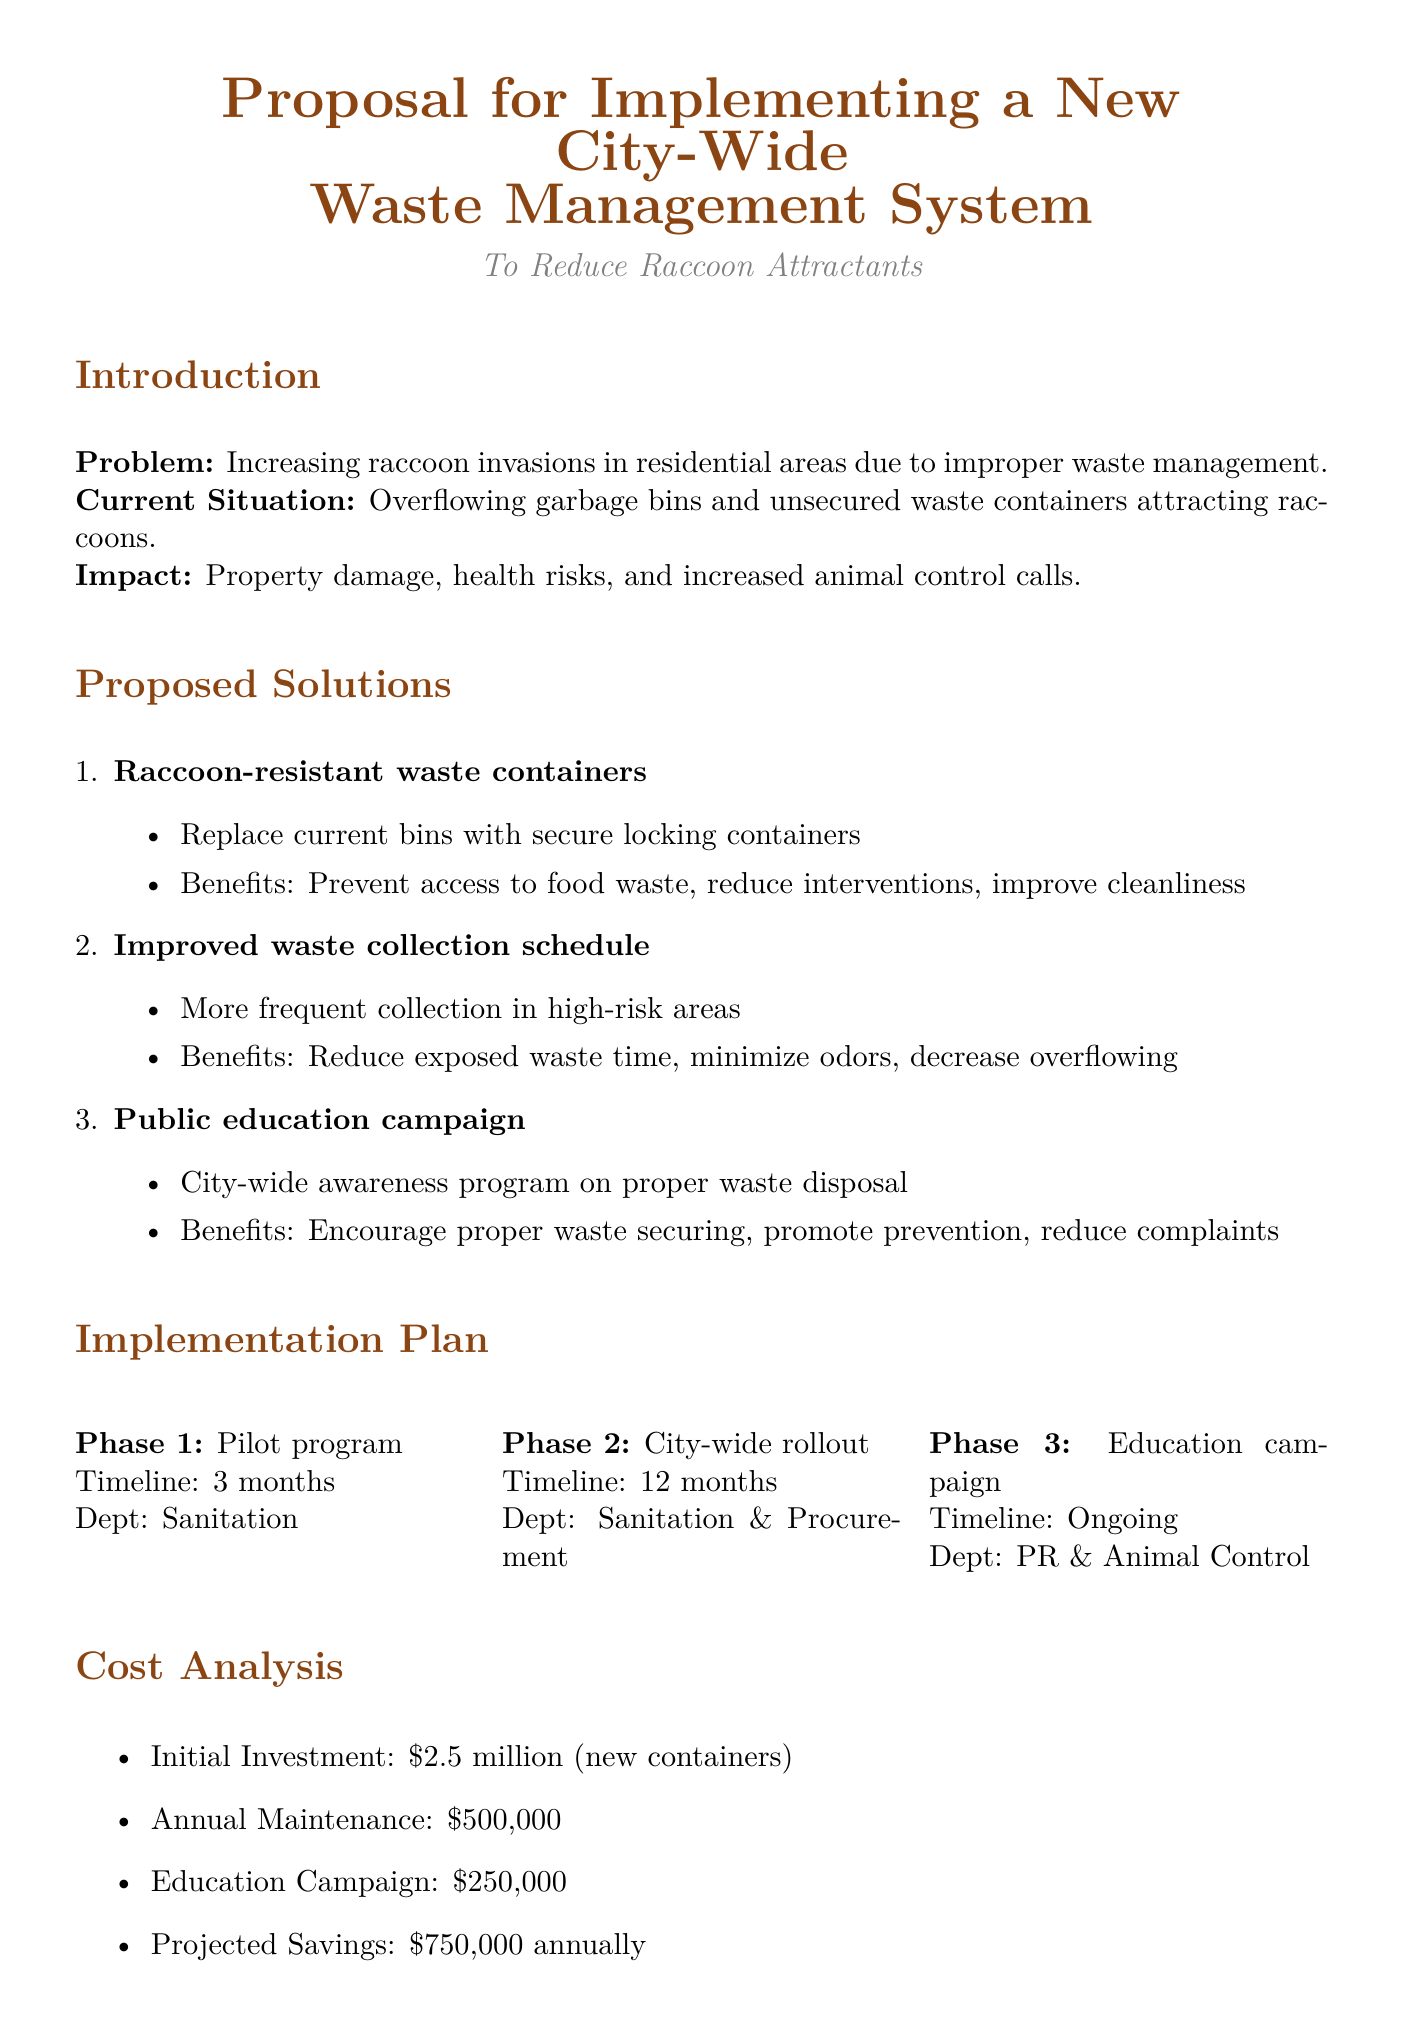What is the main problem addressed in the memo? The memo addresses the increasing raccoon invasions in residential areas due to improper waste management.
Answer: Increasing raccoon invasions What is the proposed initial investment for new waste containers? The proposed initial investment for new waste containers is explicitly stated in the cost analysis section of the document.
Answer: $2.5 million In how many months is the pilot program expected to run? The timeline for the pilot program is mentioned in the implementation plan section.
Answer: 3 months What is one benefit of raccoon-resistant waste containers? The benefits of raccoon-resistant waste containers are outlined in the proposed solutions, detailing why they are effective.
Answer: Prevent raccoons from accessing food waste Who is responsible for the public education campaign? The responsible department for the public education campaign is noted in the implementation plan.
Answer: Public Relations and Animal Control What is the expected reduction in raccoon-related incidents within the first year? The expected outcomes include specific projections regarding raccoon-related incidents, highlighting the effectiveness of the proposed plan.
Answer: 50% reduction What is the annual maintenance cost for container repairs and replacements? The annual maintenance cost is clearly stated in the cost analysis section of the document.
Answer: $500,000 What is the role of local wildlife rehabilitation centers in this proposal? The collaboration opportunities section outlines the specific roles for each partner in the initiative.
Answer: Provide expertise on raccoon behavior and humane deterrence methods What is the call to action in the conclusion? The conclusion emphasizes a specific action that is urged to be taken, which is critical for implementation.
Answer: Urge city council to approve and fund this comprehensive plan 